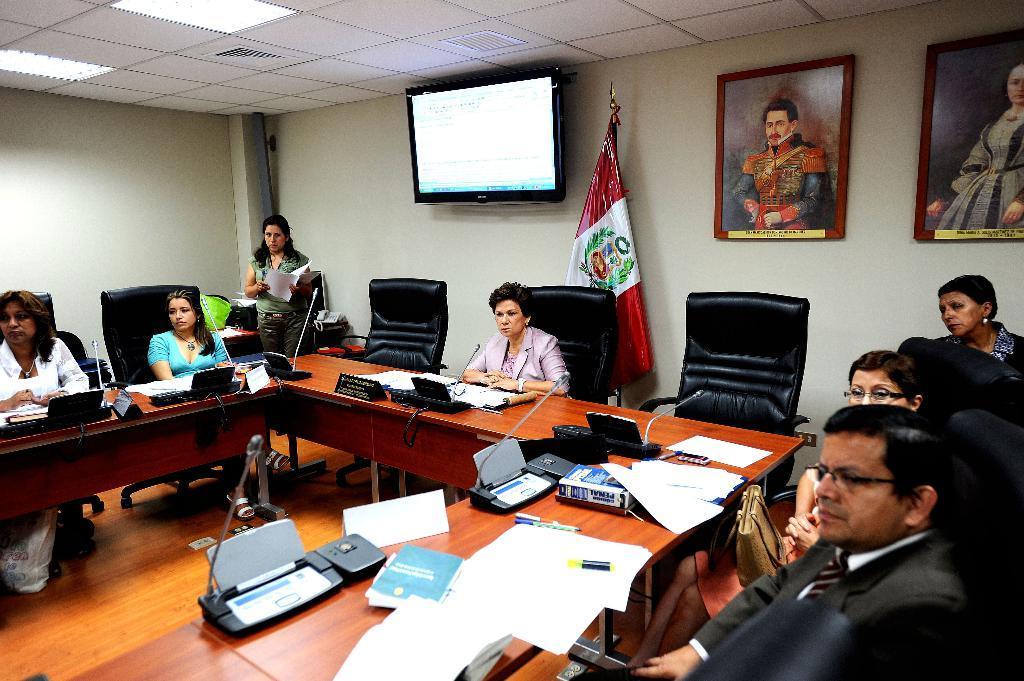Please provide a concise description of this image. This image was taken from inside of the room. In this picture people are sitting on the chairs. At the back side there is a television, flag and on the wall there are two photo frames. At the top of the roof there are fall ceiling lights and we can see tables in front of the persons and on top of the tables there are papers, name boards, pen and some other objects placed on the table. 